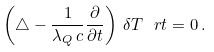<formula> <loc_0><loc_0><loc_500><loc_500>\left ( \triangle - \frac { 1 } { \lambda _ { Q } \, c } \frac { \partial } { \partial t } \right ) \, \delta T \ r t = 0 \, .</formula> 